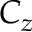Convert formula to latex. <formula><loc_0><loc_0><loc_500><loc_500>C _ { z }</formula> 